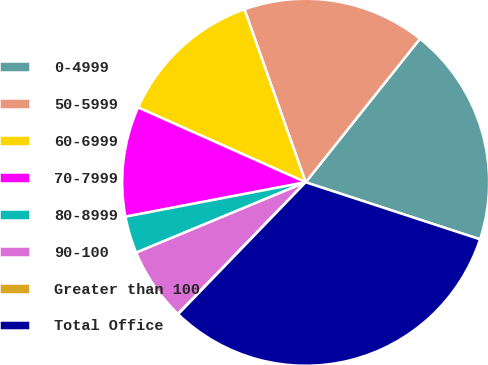Convert chart to OTSL. <chart><loc_0><loc_0><loc_500><loc_500><pie_chart><fcel>0-4999<fcel>50-5999<fcel>60-6999<fcel>70-7999<fcel>80-8999<fcel>90-100<fcel>Greater than 100<fcel>Total Office<nl><fcel>19.33%<fcel>16.12%<fcel>12.9%<fcel>9.69%<fcel>3.26%<fcel>6.47%<fcel>0.04%<fcel>32.19%<nl></chart> 